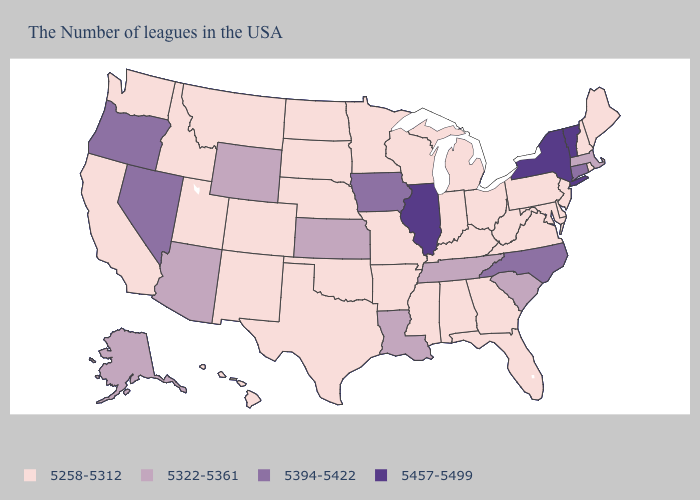Does New Jersey have the highest value in the USA?
Be succinct. No. What is the highest value in states that border Delaware?
Answer briefly. 5258-5312. Does the first symbol in the legend represent the smallest category?
Concise answer only. Yes. What is the value of Florida?
Write a very short answer. 5258-5312. What is the value of South Carolina?
Concise answer only. 5322-5361. What is the value of Washington?
Write a very short answer. 5258-5312. Which states have the highest value in the USA?
Short answer required. Vermont, New York, Illinois. What is the value of Georgia?
Keep it brief. 5258-5312. Does Maryland have the same value as New York?
Keep it brief. No. What is the lowest value in the MidWest?
Concise answer only. 5258-5312. What is the lowest value in states that border Montana?
Quick response, please. 5258-5312. Name the states that have a value in the range 5457-5499?
Short answer required. Vermont, New York, Illinois. What is the value of New York?
Give a very brief answer. 5457-5499. What is the value of Florida?
Write a very short answer. 5258-5312. 